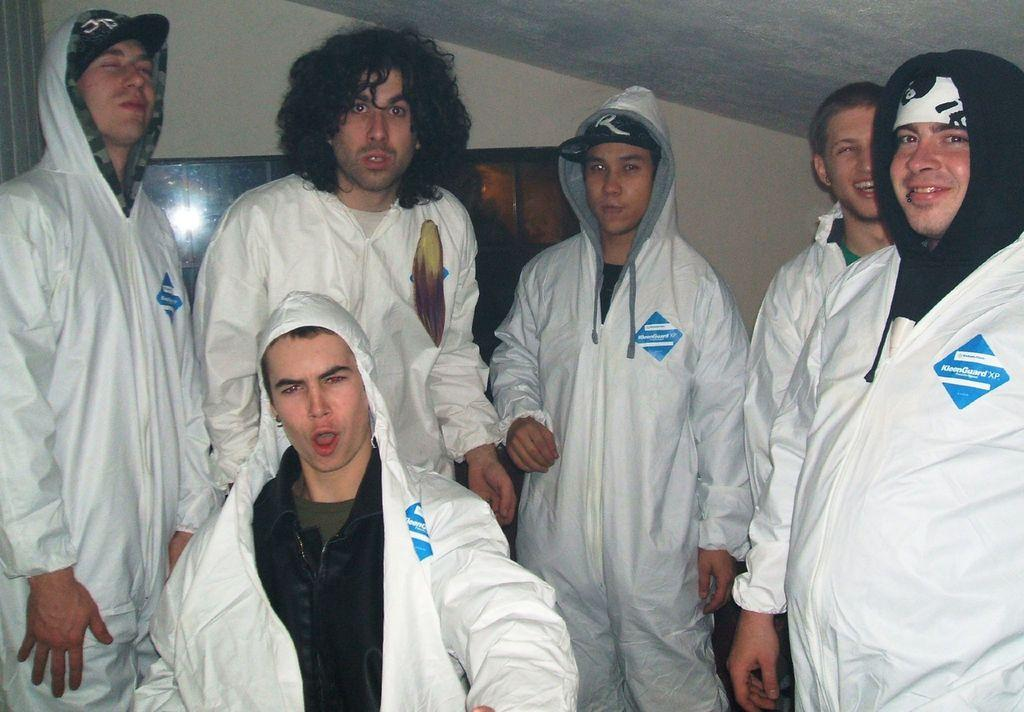<image>
Summarize the visual content of the image. A group of guys wear a white coverall with Kleenguard in a blue square. 